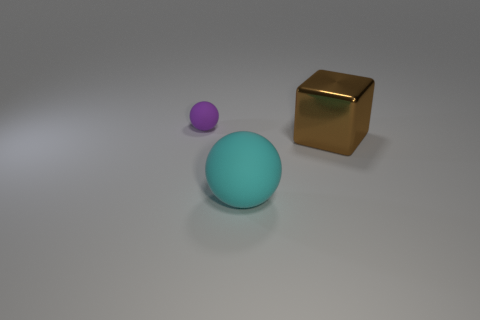Is there any other thing that has the same material as the block?
Offer a terse response. No. What is the material of the sphere in front of the purple rubber ball?
Provide a short and direct response. Rubber. Is the size of the brown metal block the same as the cyan thing?
Give a very brief answer. Yes. What number of other things are there of the same size as the purple object?
Make the answer very short. 0. There is a rubber object that is behind the large object that is to the right of the big object on the left side of the metal cube; what is its shape?
Offer a very short reply. Sphere. What number of things are either cyan things that are on the left side of the brown object or spheres in front of the metallic thing?
Offer a terse response. 1. What size is the thing that is to the right of the rubber thing in front of the large brown object?
Offer a very short reply. Large. Is there a large cyan thing that has the same shape as the tiny object?
Give a very brief answer. Yes. There is a thing that is the same size as the brown metal cube; what is its color?
Offer a very short reply. Cyan. There is a object on the right side of the large cyan matte object; what is its size?
Offer a terse response. Large. 